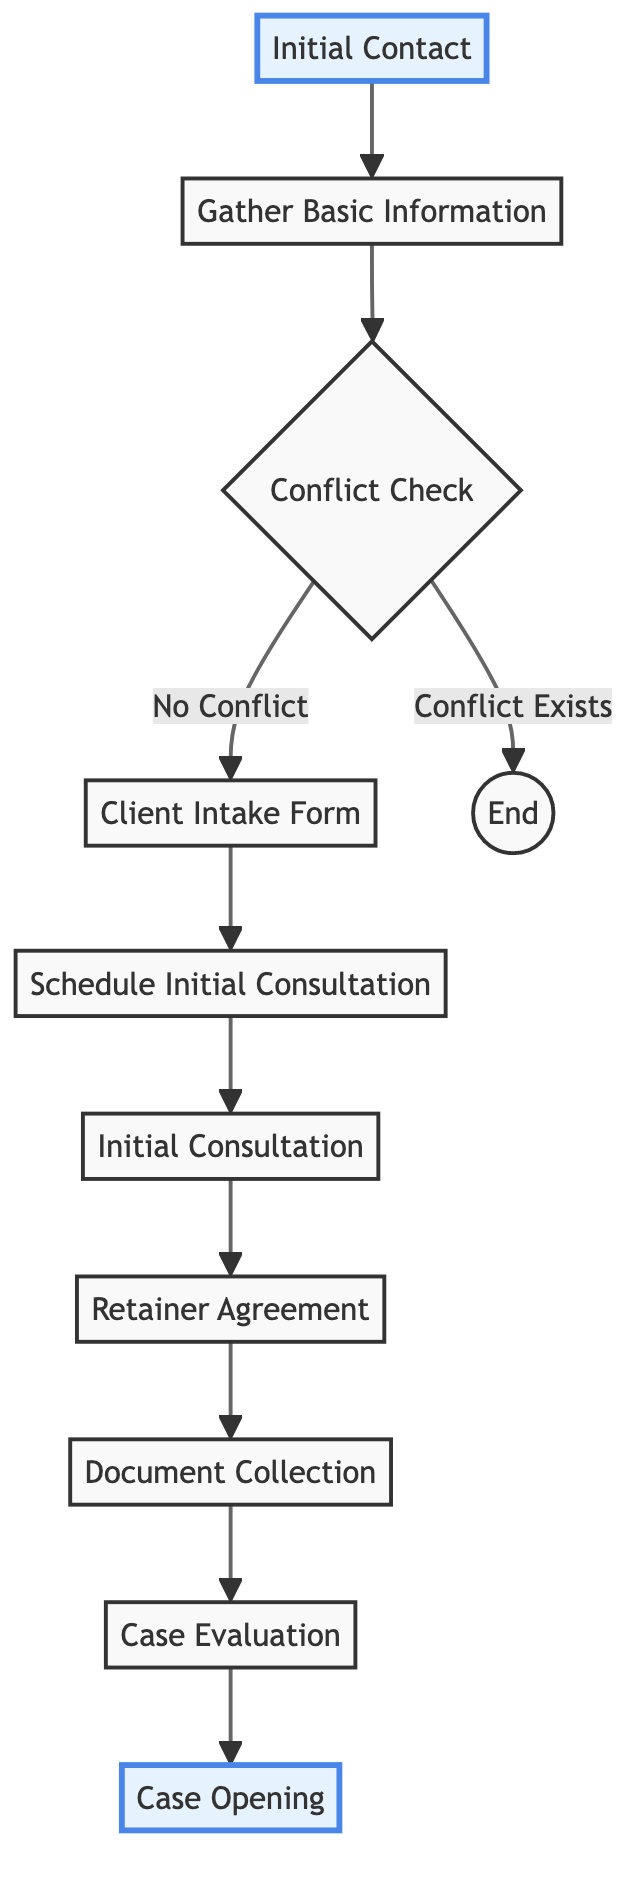What is the first step in the process? The diagram indicates that the first step in the legal case intake process is "Initial Contact." This is the entry point where the client reaches out to the law firm.
Answer: Initial Contact How many total steps are present in the diagram? By counting the nodes in the diagram, there are a total of 10 steps in the legal case intake process. The steps include Initial Contact, Gather Basic Information, Conflict Check, Client Intake Form, Schedule Initial Consultation, Initial Consultation, Retainer Agreement, Document Collection, Case Evaluation, and Case Opening.
Answer: 10 What happens if there is a conflict of interest? The diagram shows that if a conflict exists during the "Conflict Check," the process leads to "End," indicating the termination of the case intake process as the firm cannot take on the new client.
Answer: End After gathering basic information, which step follows if there is no conflict? According to the diagram, after gathering basic information, if there is no conflict identified, the next step is "Client Intake Form," where the firm assists the client in completing the form.
Answer: Client Intake Form What is the final step in this flow chart? The last step depicted in the diagram is "Case Opening," where a case file is created in the firm's case management system after evaluating the collected documents and developing a legal strategy.
Answer: Case Opening During which step do clients sign the agreement? The diagram specifies that clients sign the retainer agreement during the "Retainer Agreement" step. This step entails discussing and formalizing the scope of services and payment structure with the client.
Answer: Retainer Agreement Which step directly follows the initial consultation? Following the "Initial Consultation," the next step in the diagram is "Retainer Agreement." This step is crucial as it lays out the terms of the working relationship between the client and the firm.
Answer: Retainer Agreement What document is collected during the document collection step? The diagram outlines that during the "Document Collection" step, the law firm collects relevant documents and evidence from the client to support their case.
Answer: Relevant documents and evidence What action is taken after scheduling the initial consultation? After "Scheduling Initial Consultation," the diagram indicates that the client meets with the lawyer in the "Initial Consultation" step to discuss the case in detail and provide preliminary advice.
Answer: Initial Consultation 